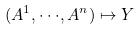<formula> <loc_0><loc_0><loc_500><loc_500>( A ^ { 1 } , \cdot \cdot \cdot , A ^ { n } ) \mapsto Y</formula> 